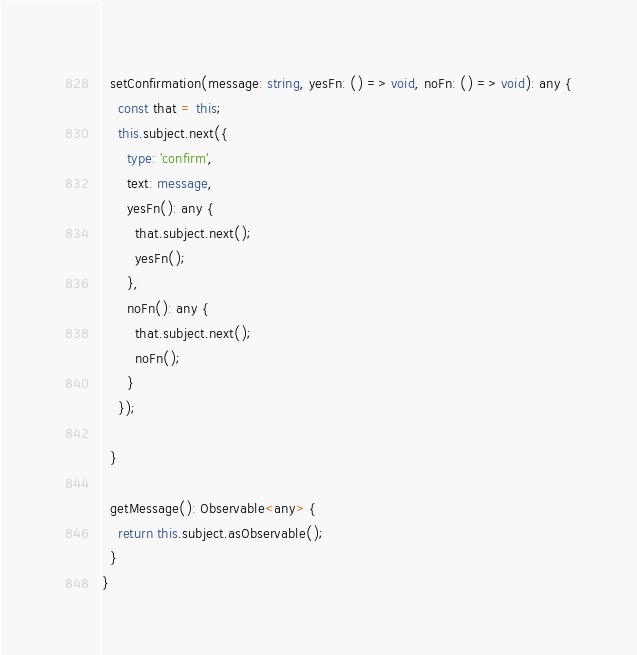<code> <loc_0><loc_0><loc_500><loc_500><_TypeScript_>
  setConfirmation(message: string, yesFn: () => void, noFn: () => void): any {
    const that = this;
    this.subject.next({
      type: 'confirm',
      text: message,
      yesFn(): any {
        that.subject.next();
        yesFn();
      },
      noFn(): any {
        that.subject.next();
        noFn();
      }
    });

  }

  getMessage(): Observable<any> {
    return this.subject.asObservable();
  }
}
</code> 